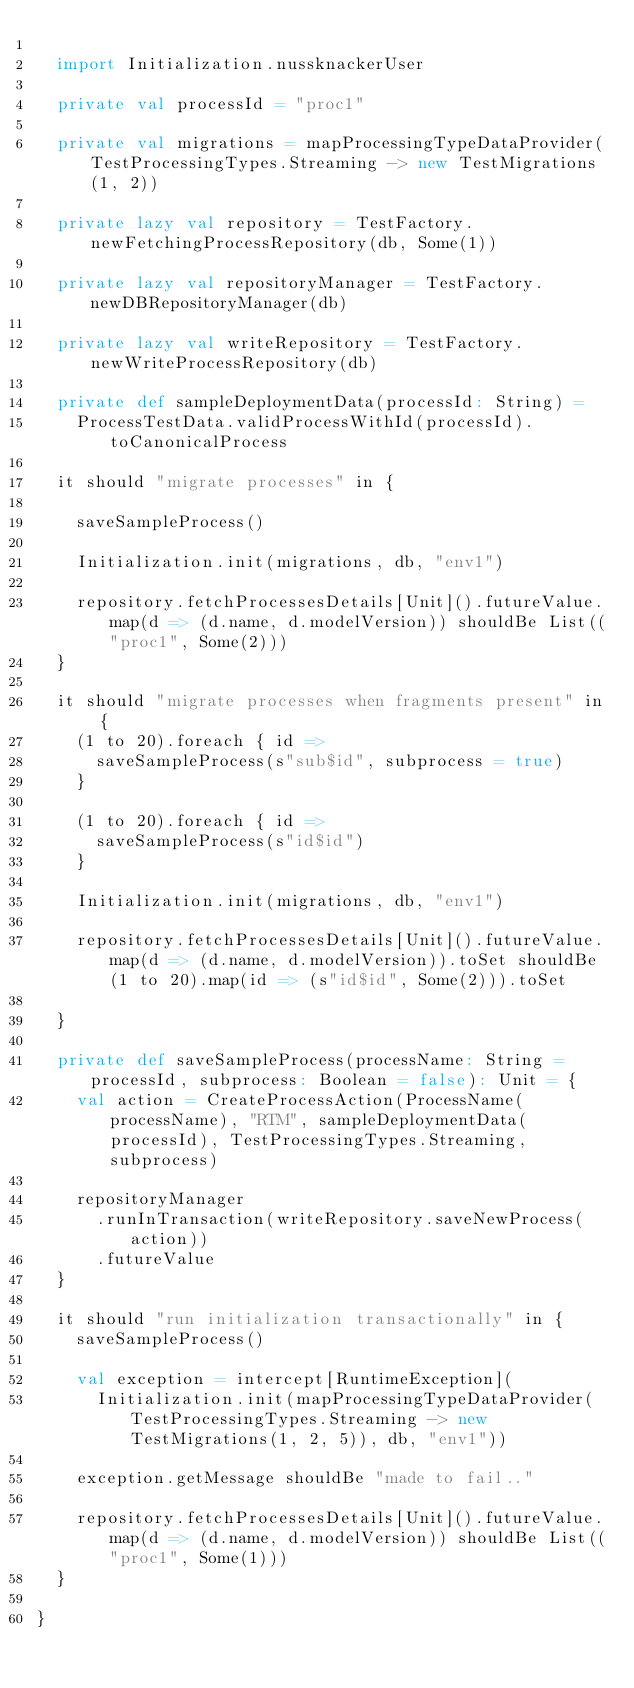<code> <loc_0><loc_0><loc_500><loc_500><_Scala_>
  import Initialization.nussknackerUser

  private val processId = "proc1"

  private val migrations = mapProcessingTypeDataProvider(TestProcessingTypes.Streaming -> new TestMigrations(1, 2))

  private lazy val repository = TestFactory.newFetchingProcessRepository(db, Some(1))

  private lazy val repositoryManager = TestFactory.newDBRepositoryManager(db)

  private lazy val writeRepository = TestFactory.newWriteProcessRepository(db)

  private def sampleDeploymentData(processId: String) =
    ProcessTestData.validProcessWithId(processId).toCanonicalProcess

  it should "migrate processes" in {

    saveSampleProcess()

    Initialization.init(migrations, db, "env1")

    repository.fetchProcessesDetails[Unit]().futureValue.map(d => (d.name, d.modelVersion)) shouldBe List(("proc1", Some(2)))
  }

  it should "migrate processes when fragments present" in {
    (1 to 20).foreach { id =>
      saveSampleProcess(s"sub$id", subprocess = true)
    }

    (1 to 20).foreach { id =>
      saveSampleProcess(s"id$id")
    }

    Initialization.init(migrations, db, "env1")

    repository.fetchProcessesDetails[Unit]().futureValue.map(d => (d.name, d.modelVersion)).toSet shouldBe (1 to 20).map(id => (s"id$id", Some(2))).toSet

  }

  private def saveSampleProcess(processName: String = processId, subprocess: Boolean = false): Unit = {
    val action = CreateProcessAction(ProcessName(processName), "RTM", sampleDeploymentData(processId), TestProcessingTypes.Streaming, subprocess)

    repositoryManager
      .runInTransaction(writeRepository.saveNewProcess(action))
      .futureValue
  }

  it should "run initialization transactionally" in {
    saveSampleProcess()

    val exception = intercept[RuntimeException](
      Initialization.init(mapProcessingTypeDataProvider(TestProcessingTypes.Streaming -> new TestMigrations(1, 2, 5)), db, "env1"))

    exception.getMessage shouldBe "made to fail.."

    repository.fetchProcessesDetails[Unit]().futureValue.map(d => (d.name, d.modelVersion)) shouldBe List(("proc1", Some(1)))
  }

}
</code> 